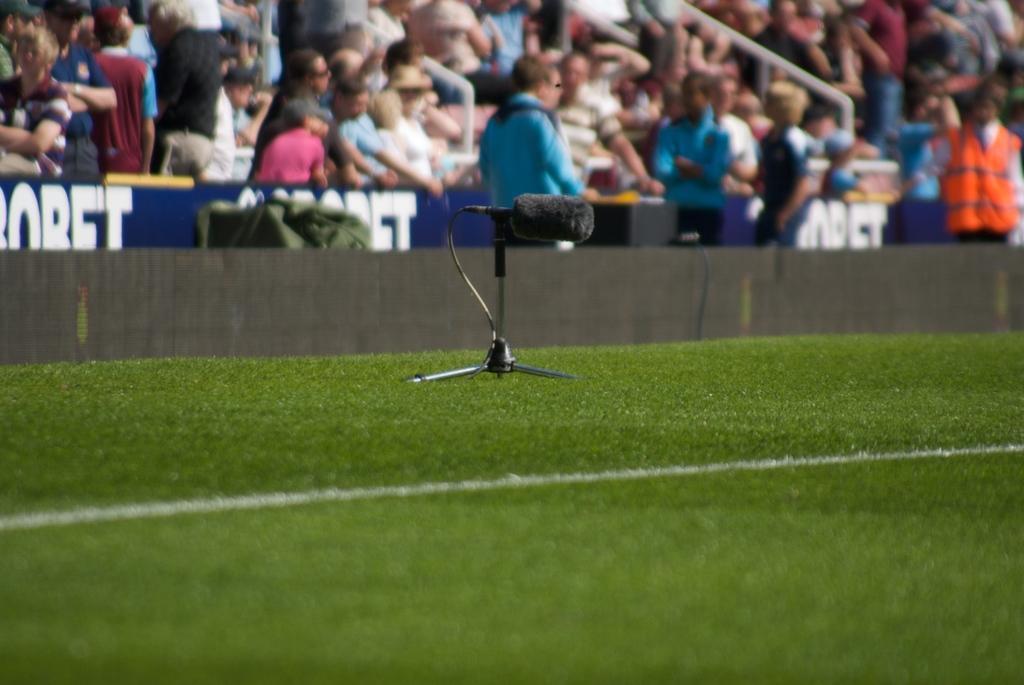Can you describe this image briefly? In the foreground of the picture we can see grass, stand, cable and mic. In the middle of the picture there are people, boards and some other objects. At the top there are people and hand railings. 